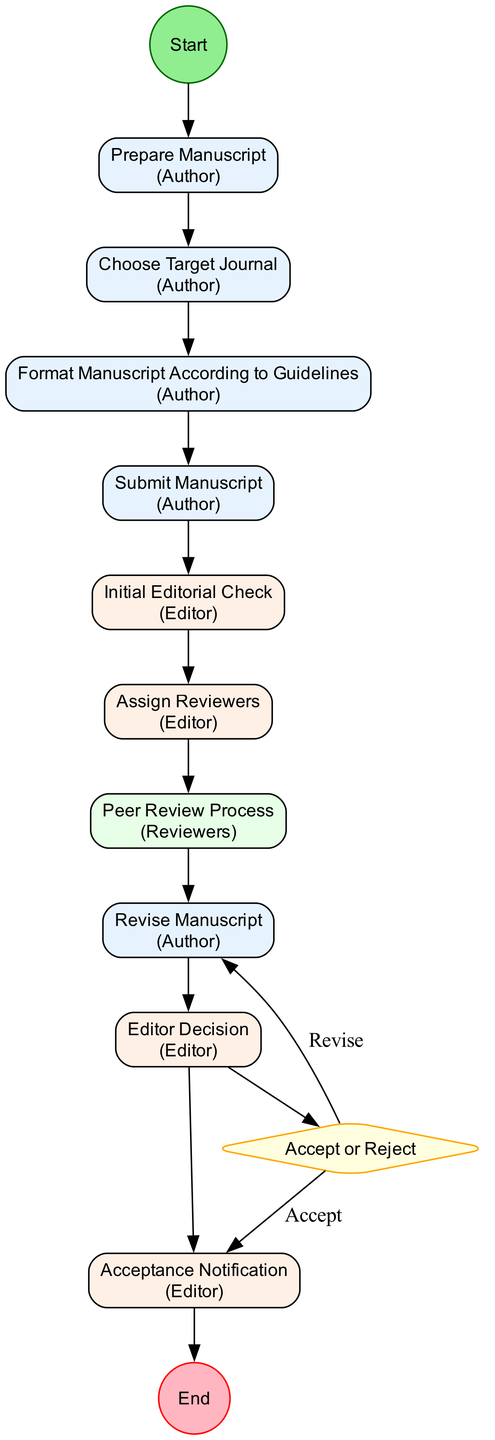What is the first activity in the workflow? The first activity is "Prepare Manuscript," which is represented as the first node following the start event in the diagram.
Answer: Prepare Manuscript How many total activities are represented in the diagram? The diagram includes 10 distinct activities, each contributing to the workflow from preparation to acceptance.
Answer: 10 Who is responsible for the "Initial Editorial Check"? The "Initial Editorial Check" is conducted by the Editor, as indicated next to the corresponding activity in the diagram.
Answer: Editor What happens if the decision is to "Reject"? If the decision is to "Reject," the workflow diverges, and there would be no subsequent activities leading to acceptance, which leads to an end point without acceptance notification.
Answer: Manuscript is rejected Which activity does the "Accept" decision lead to? The "Accept" decision leads directly to the "Acceptance Notification" activity, indicating a successful outcome for the manuscript.
Answer: Acceptance Notification After the "Peer Review Process," which activity occurs next? After the "Peer Review Process," the next activity is the "Editor Decision," where the editor decides based on the reviewers' feedback.
Answer: Editor Decision How many decision points are in the diagram? There is only one decision point represented in the workflow, which is the "Accept or Reject" decision made by the editor.
Answer: 1 What color represents activities performed by the Author? Activities performed by the Author are represented in a light blue color (#E6F3FF) in the diagram's node color coding.
Answer: Light blue What is the final event in the workflow? The final event in the journal publication workflow is the "End," which signifies the conclusion of the process when the manuscript is accepted.
Answer: End 